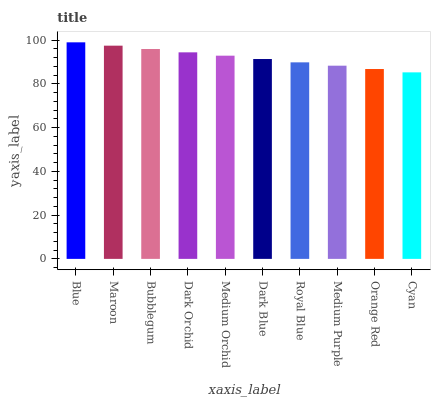Is Cyan the minimum?
Answer yes or no. Yes. Is Blue the maximum?
Answer yes or no. Yes. Is Maroon the minimum?
Answer yes or no. No. Is Maroon the maximum?
Answer yes or no. No. Is Blue greater than Maroon?
Answer yes or no. Yes. Is Maroon less than Blue?
Answer yes or no. Yes. Is Maroon greater than Blue?
Answer yes or no. No. Is Blue less than Maroon?
Answer yes or no. No. Is Medium Orchid the high median?
Answer yes or no. Yes. Is Dark Blue the low median?
Answer yes or no. Yes. Is Blue the high median?
Answer yes or no. No. Is Bubblegum the low median?
Answer yes or no. No. 